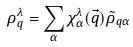<formula> <loc_0><loc_0><loc_500><loc_500>\rho ^ { \lambda } _ { q } = \sum _ { \alpha } \chi ^ { \lambda } _ { \alpha } ( \vec { q } ) \tilde { \rho } _ { q \alpha }</formula> 